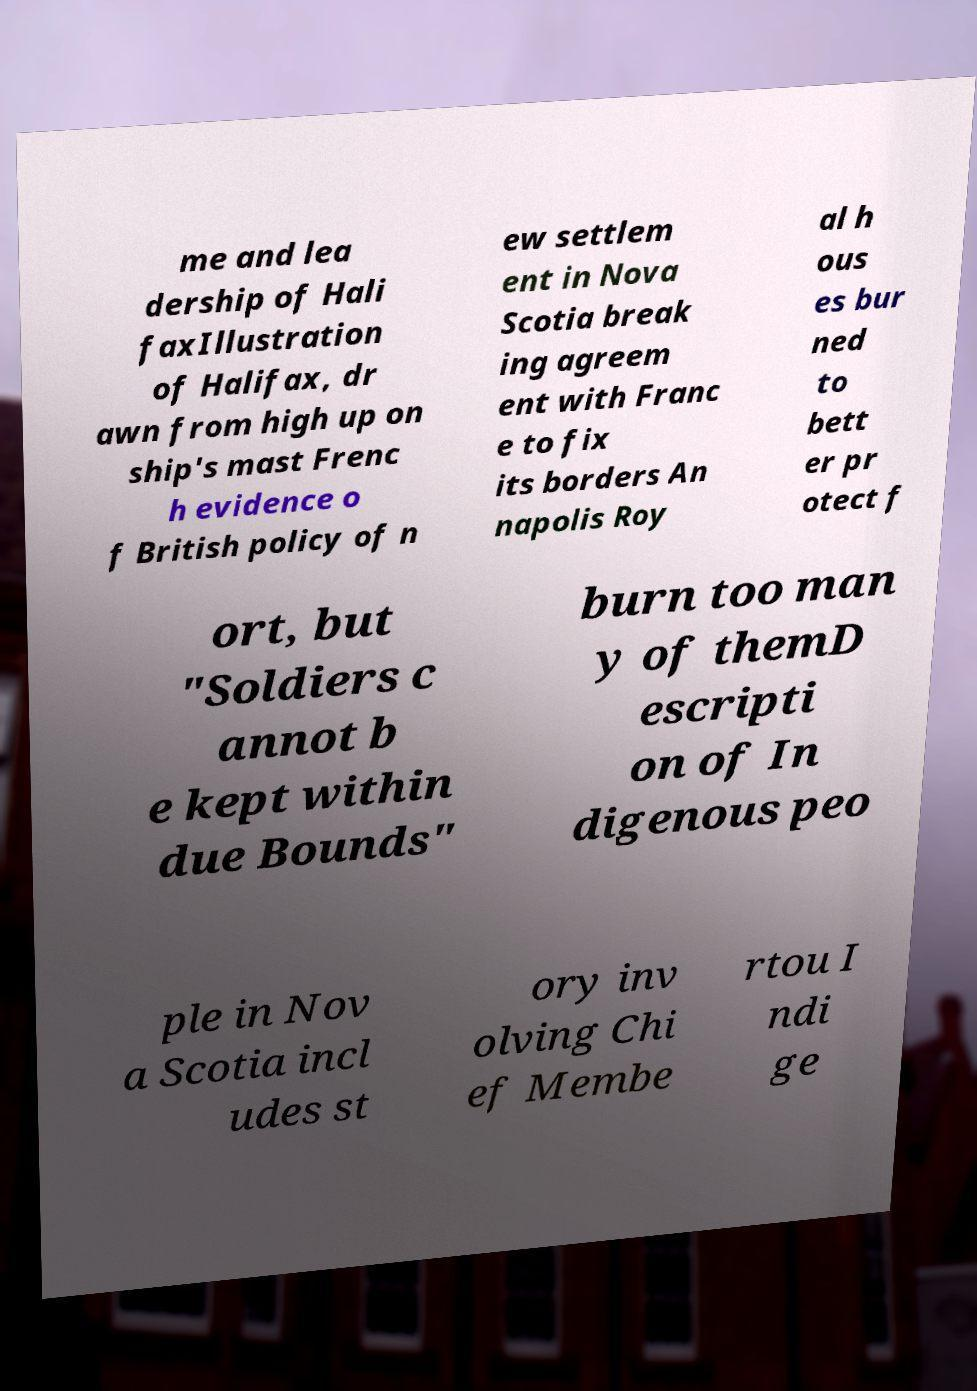There's text embedded in this image that I need extracted. Can you transcribe it verbatim? me and lea dership of Hali faxIllustration of Halifax, dr awn from high up on ship's mast Frenc h evidence o f British policy of n ew settlem ent in Nova Scotia break ing agreem ent with Franc e to fix its borders An napolis Roy al h ous es bur ned to bett er pr otect f ort, but "Soldiers c annot b e kept within due Bounds" burn too man y of themD escripti on of In digenous peo ple in Nov a Scotia incl udes st ory inv olving Chi ef Membe rtou I ndi ge 